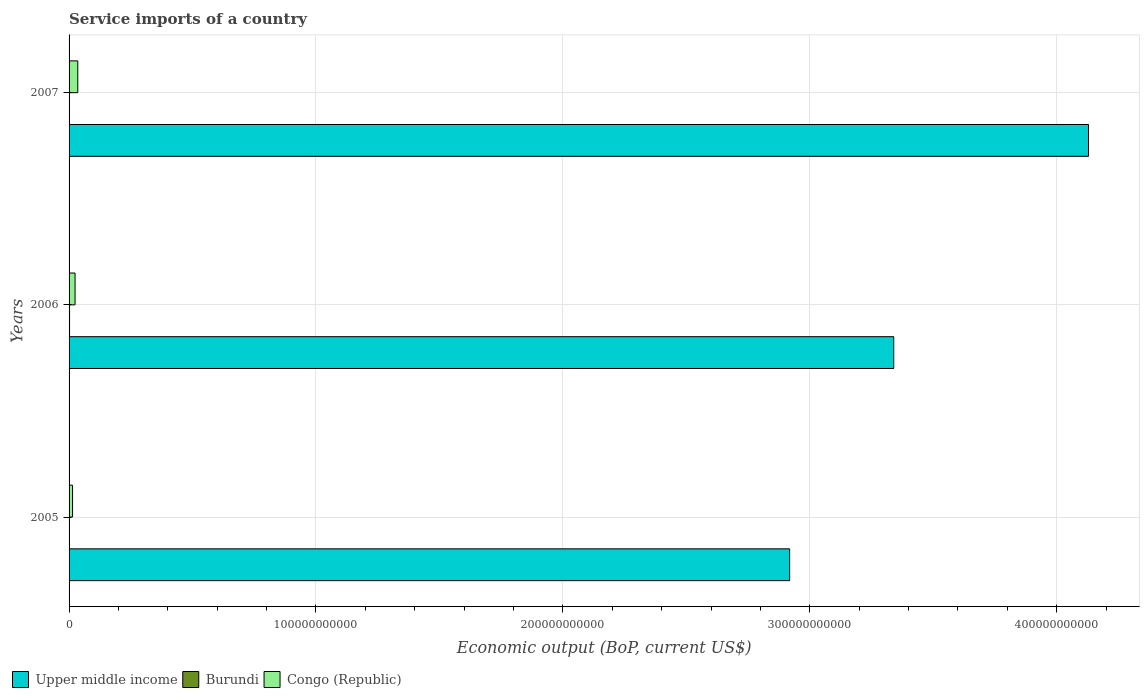How many groups of bars are there?
Your answer should be very brief. 3. Are the number of bars per tick equal to the number of legend labels?
Make the answer very short. Yes. How many bars are there on the 1st tick from the top?
Provide a succinct answer. 3. How many bars are there on the 2nd tick from the bottom?
Keep it short and to the point. 3. What is the service imports in Upper middle income in 2007?
Offer a terse response. 4.13e+11. Across all years, what is the maximum service imports in Congo (Republic)?
Give a very brief answer. 3.53e+09. Across all years, what is the minimum service imports in Burundi?
Give a very brief answer. 1.34e+08. In which year was the service imports in Upper middle income minimum?
Your answer should be compact. 2005. What is the total service imports in Burundi in the graph?
Provide a short and direct response. 5.18e+08. What is the difference between the service imports in Congo (Republic) in 2006 and that in 2007?
Give a very brief answer. -1.10e+09. What is the difference between the service imports in Burundi in 2006 and the service imports in Congo (Republic) in 2005?
Your answer should be very brief. -1.21e+09. What is the average service imports in Burundi per year?
Ensure brevity in your answer.  1.73e+08. In the year 2006, what is the difference between the service imports in Burundi and service imports in Congo (Republic)?
Make the answer very short. -2.22e+09. What is the ratio of the service imports in Burundi in 2005 to that in 2007?
Ensure brevity in your answer.  0.74. What is the difference between the highest and the second highest service imports in Upper middle income?
Your response must be concise. 7.89e+1. What is the difference between the highest and the lowest service imports in Upper middle income?
Ensure brevity in your answer.  1.21e+11. What does the 2nd bar from the top in 2005 represents?
Your response must be concise. Burundi. What does the 3rd bar from the bottom in 2007 represents?
Provide a short and direct response. Congo (Republic). Is it the case that in every year, the sum of the service imports in Burundi and service imports in Upper middle income is greater than the service imports in Congo (Republic)?
Provide a short and direct response. Yes. Are all the bars in the graph horizontal?
Offer a terse response. Yes. How many years are there in the graph?
Keep it short and to the point. 3. What is the difference between two consecutive major ticks on the X-axis?
Provide a succinct answer. 1.00e+11. Are the values on the major ticks of X-axis written in scientific E-notation?
Your response must be concise. No. Does the graph contain any zero values?
Keep it short and to the point. No. How many legend labels are there?
Make the answer very short. 3. What is the title of the graph?
Your answer should be compact. Service imports of a country. Does "Panama" appear as one of the legend labels in the graph?
Your answer should be compact. No. What is the label or title of the X-axis?
Keep it short and to the point. Economic output (BoP, current US$). What is the label or title of the Y-axis?
Give a very brief answer. Years. What is the Economic output (BoP, current US$) of Upper middle income in 2005?
Ensure brevity in your answer.  2.92e+11. What is the Economic output (BoP, current US$) in Burundi in 2005?
Your response must be concise. 1.34e+08. What is the Economic output (BoP, current US$) in Congo (Republic) in 2005?
Your response must be concise. 1.42e+09. What is the Economic output (BoP, current US$) in Upper middle income in 2006?
Give a very brief answer. 3.34e+11. What is the Economic output (BoP, current US$) of Burundi in 2006?
Your answer should be very brief. 2.02e+08. What is the Economic output (BoP, current US$) of Congo (Republic) in 2006?
Ensure brevity in your answer.  2.43e+09. What is the Economic output (BoP, current US$) of Upper middle income in 2007?
Provide a succinct answer. 4.13e+11. What is the Economic output (BoP, current US$) in Burundi in 2007?
Provide a short and direct response. 1.82e+08. What is the Economic output (BoP, current US$) of Congo (Republic) in 2007?
Your answer should be very brief. 3.53e+09. Across all years, what is the maximum Economic output (BoP, current US$) of Upper middle income?
Your response must be concise. 4.13e+11. Across all years, what is the maximum Economic output (BoP, current US$) in Burundi?
Provide a short and direct response. 2.02e+08. Across all years, what is the maximum Economic output (BoP, current US$) of Congo (Republic)?
Offer a very short reply. 3.53e+09. Across all years, what is the minimum Economic output (BoP, current US$) in Upper middle income?
Provide a succinct answer. 2.92e+11. Across all years, what is the minimum Economic output (BoP, current US$) in Burundi?
Give a very brief answer. 1.34e+08. Across all years, what is the minimum Economic output (BoP, current US$) of Congo (Republic)?
Your answer should be compact. 1.42e+09. What is the total Economic output (BoP, current US$) in Upper middle income in the graph?
Keep it short and to the point. 1.04e+12. What is the total Economic output (BoP, current US$) in Burundi in the graph?
Keep it short and to the point. 5.18e+08. What is the total Economic output (BoP, current US$) of Congo (Republic) in the graph?
Make the answer very short. 7.37e+09. What is the difference between the Economic output (BoP, current US$) of Upper middle income in 2005 and that in 2006?
Your answer should be compact. -4.22e+1. What is the difference between the Economic output (BoP, current US$) in Burundi in 2005 and that in 2006?
Offer a very short reply. -6.81e+07. What is the difference between the Economic output (BoP, current US$) in Congo (Republic) in 2005 and that in 2006?
Keep it short and to the point. -1.01e+09. What is the difference between the Economic output (BoP, current US$) of Upper middle income in 2005 and that in 2007?
Make the answer very short. -1.21e+11. What is the difference between the Economic output (BoP, current US$) in Burundi in 2005 and that in 2007?
Keep it short and to the point. -4.81e+07. What is the difference between the Economic output (BoP, current US$) of Congo (Republic) in 2005 and that in 2007?
Provide a short and direct response. -2.11e+09. What is the difference between the Economic output (BoP, current US$) of Upper middle income in 2006 and that in 2007?
Ensure brevity in your answer.  -7.89e+1. What is the difference between the Economic output (BoP, current US$) in Burundi in 2006 and that in 2007?
Provide a short and direct response. 2.01e+07. What is the difference between the Economic output (BoP, current US$) in Congo (Republic) in 2006 and that in 2007?
Offer a very short reply. -1.10e+09. What is the difference between the Economic output (BoP, current US$) of Upper middle income in 2005 and the Economic output (BoP, current US$) of Burundi in 2006?
Ensure brevity in your answer.  2.92e+11. What is the difference between the Economic output (BoP, current US$) of Upper middle income in 2005 and the Economic output (BoP, current US$) of Congo (Republic) in 2006?
Make the answer very short. 2.89e+11. What is the difference between the Economic output (BoP, current US$) in Burundi in 2005 and the Economic output (BoP, current US$) in Congo (Republic) in 2006?
Give a very brief answer. -2.29e+09. What is the difference between the Economic output (BoP, current US$) in Upper middle income in 2005 and the Economic output (BoP, current US$) in Burundi in 2007?
Your answer should be very brief. 2.92e+11. What is the difference between the Economic output (BoP, current US$) of Upper middle income in 2005 and the Economic output (BoP, current US$) of Congo (Republic) in 2007?
Provide a succinct answer. 2.88e+11. What is the difference between the Economic output (BoP, current US$) of Burundi in 2005 and the Economic output (BoP, current US$) of Congo (Republic) in 2007?
Make the answer very short. -3.39e+09. What is the difference between the Economic output (BoP, current US$) of Upper middle income in 2006 and the Economic output (BoP, current US$) of Burundi in 2007?
Your response must be concise. 3.34e+11. What is the difference between the Economic output (BoP, current US$) in Upper middle income in 2006 and the Economic output (BoP, current US$) in Congo (Republic) in 2007?
Keep it short and to the point. 3.30e+11. What is the difference between the Economic output (BoP, current US$) of Burundi in 2006 and the Economic output (BoP, current US$) of Congo (Republic) in 2007?
Your answer should be compact. -3.33e+09. What is the average Economic output (BoP, current US$) in Upper middle income per year?
Your answer should be very brief. 3.46e+11. What is the average Economic output (BoP, current US$) of Burundi per year?
Give a very brief answer. 1.73e+08. What is the average Economic output (BoP, current US$) in Congo (Republic) per year?
Keep it short and to the point. 2.46e+09. In the year 2005, what is the difference between the Economic output (BoP, current US$) in Upper middle income and Economic output (BoP, current US$) in Burundi?
Offer a terse response. 2.92e+11. In the year 2005, what is the difference between the Economic output (BoP, current US$) of Upper middle income and Economic output (BoP, current US$) of Congo (Republic)?
Your answer should be compact. 2.90e+11. In the year 2005, what is the difference between the Economic output (BoP, current US$) of Burundi and Economic output (BoP, current US$) of Congo (Republic)?
Offer a very short reply. -1.28e+09. In the year 2006, what is the difference between the Economic output (BoP, current US$) of Upper middle income and Economic output (BoP, current US$) of Burundi?
Your answer should be very brief. 3.34e+11. In the year 2006, what is the difference between the Economic output (BoP, current US$) of Upper middle income and Economic output (BoP, current US$) of Congo (Republic)?
Keep it short and to the point. 3.32e+11. In the year 2006, what is the difference between the Economic output (BoP, current US$) in Burundi and Economic output (BoP, current US$) in Congo (Republic)?
Provide a succinct answer. -2.22e+09. In the year 2007, what is the difference between the Economic output (BoP, current US$) in Upper middle income and Economic output (BoP, current US$) in Burundi?
Your answer should be very brief. 4.13e+11. In the year 2007, what is the difference between the Economic output (BoP, current US$) of Upper middle income and Economic output (BoP, current US$) of Congo (Republic)?
Offer a very short reply. 4.09e+11. In the year 2007, what is the difference between the Economic output (BoP, current US$) in Burundi and Economic output (BoP, current US$) in Congo (Republic)?
Provide a succinct answer. -3.35e+09. What is the ratio of the Economic output (BoP, current US$) in Upper middle income in 2005 to that in 2006?
Provide a short and direct response. 0.87. What is the ratio of the Economic output (BoP, current US$) in Burundi in 2005 to that in 2006?
Ensure brevity in your answer.  0.66. What is the ratio of the Economic output (BoP, current US$) of Congo (Republic) in 2005 to that in 2006?
Your answer should be compact. 0.58. What is the ratio of the Economic output (BoP, current US$) in Upper middle income in 2005 to that in 2007?
Offer a very short reply. 0.71. What is the ratio of the Economic output (BoP, current US$) in Burundi in 2005 to that in 2007?
Keep it short and to the point. 0.74. What is the ratio of the Economic output (BoP, current US$) of Congo (Republic) in 2005 to that in 2007?
Make the answer very short. 0.4. What is the ratio of the Economic output (BoP, current US$) of Upper middle income in 2006 to that in 2007?
Offer a very short reply. 0.81. What is the ratio of the Economic output (BoP, current US$) in Burundi in 2006 to that in 2007?
Your answer should be very brief. 1.11. What is the ratio of the Economic output (BoP, current US$) in Congo (Republic) in 2006 to that in 2007?
Keep it short and to the point. 0.69. What is the difference between the highest and the second highest Economic output (BoP, current US$) in Upper middle income?
Give a very brief answer. 7.89e+1. What is the difference between the highest and the second highest Economic output (BoP, current US$) of Burundi?
Provide a short and direct response. 2.01e+07. What is the difference between the highest and the second highest Economic output (BoP, current US$) in Congo (Republic)?
Give a very brief answer. 1.10e+09. What is the difference between the highest and the lowest Economic output (BoP, current US$) in Upper middle income?
Your answer should be compact. 1.21e+11. What is the difference between the highest and the lowest Economic output (BoP, current US$) in Burundi?
Offer a very short reply. 6.81e+07. What is the difference between the highest and the lowest Economic output (BoP, current US$) of Congo (Republic)?
Your response must be concise. 2.11e+09. 